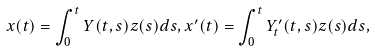<formula> <loc_0><loc_0><loc_500><loc_500>x ( t ) = \int _ { 0 } ^ { t } Y ( t , s ) z ( s ) d s , x ^ { \prime } ( t ) = \int _ { 0 } ^ { t } Y ^ { \prime } _ { t } ( t , s ) z ( s ) d s ,</formula> 